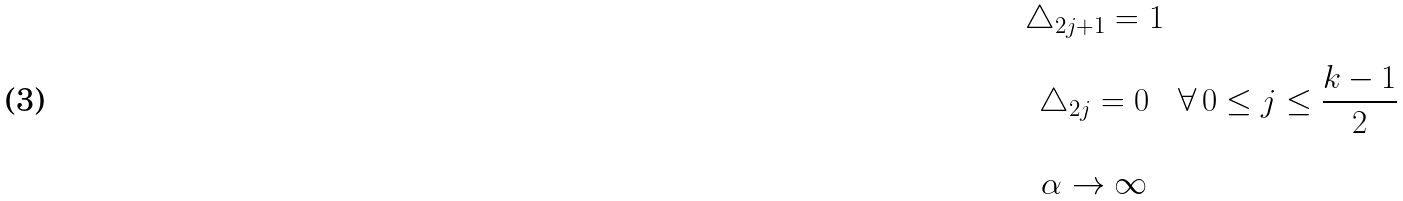<formula> <loc_0><loc_0><loc_500><loc_500>\begin{array} { c } \triangle _ { 2 j + 1 } = 1 \\ \\ \triangle _ { 2 j } = 0 \\ \\ \alpha \rightarrow \infty \end{array} \, \forall \, 0 \leq j \leq \frac { k - 1 } 2</formula> 